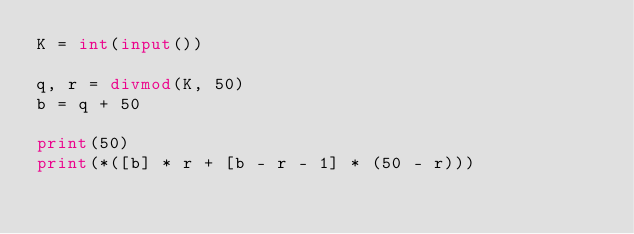Convert code to text. <code><loc_0><loc_0><loc_500><loc_500><_Python_>K = int(input())

q, r = divmod(K, 50)
b = q + 50

print(50)
print(*([b] * r + [b - r - 1] * (50 - r)))
</code> 